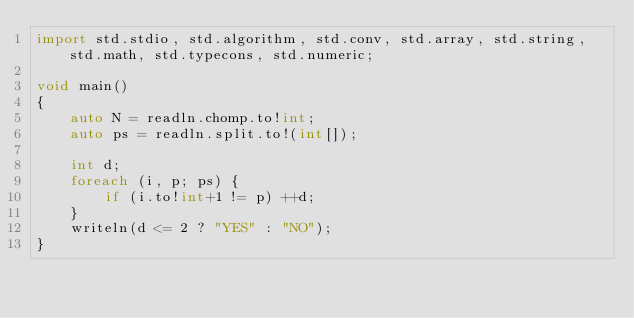<code> <loc_0><loc_0><loc_500><loc_500><_D_>import std.stdio, std.algorithm, std.conv, std.array, std.string, std.math, std.typecons, std.numeric;

void main()
{
    auto N = readln.chomp.to!int;
    auto ps = readln.split.to!(int[]);

    int d;
    foreach (i, p; ps) {
        if (i.to!int+1 != p) ++d;
    }
    writeln(d <= 2 ? "YES" : "NO");
}</code> 